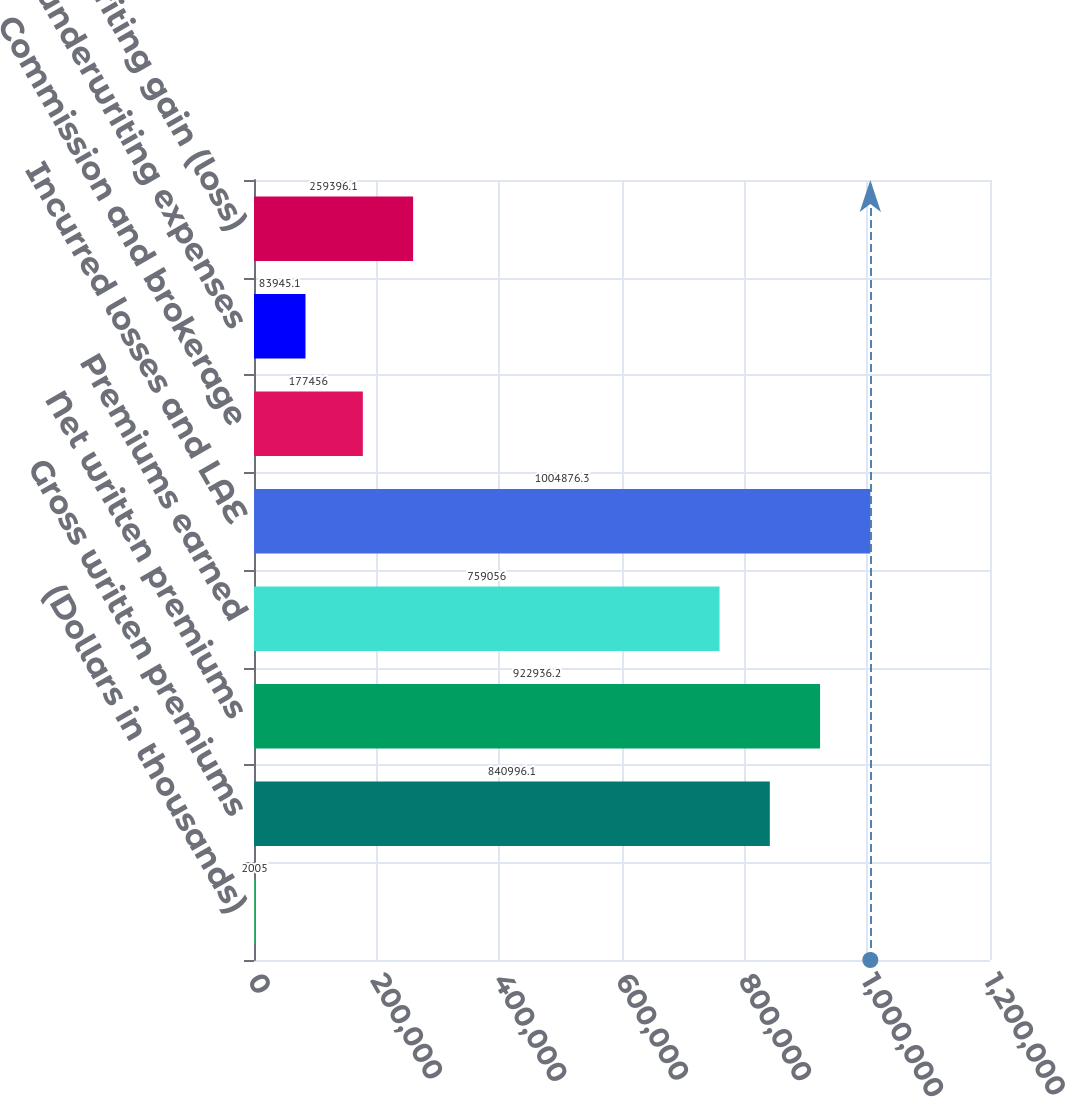Convert chart. <chart><loc_0><loc_0><loc_500><loc_500><bar_chart><fcel>(Dollars in thousands)<fcel>Gross written premiums<fcel>Net written premiums<fcel>Premiums earned<fcel>Incurred losses and LAE<fcel>Commission and brokerage<fcel>Other underwriting expenses<fcel>Underwriting gain (loss)<nl><fcel>2005<fcel>840996<fcel>922936<fcel>759056<fcel>1.00488e+06<fcel>177456<fcel>83945.1<fcel>259396<nl></chart> 